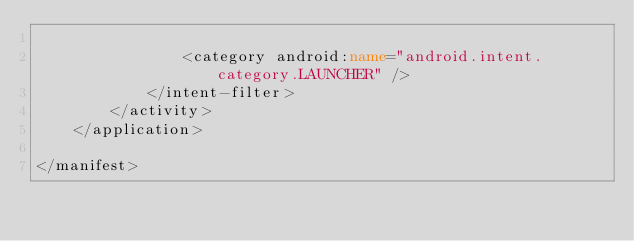Convert code to text. <code><loc_0><loc_0><loc_500><loc_500><_XML_>
                <category android:name="android.intent.category.LAUNCHER" />
            </intent-filter>
        </activity>
    </application>

</manifest></code> 